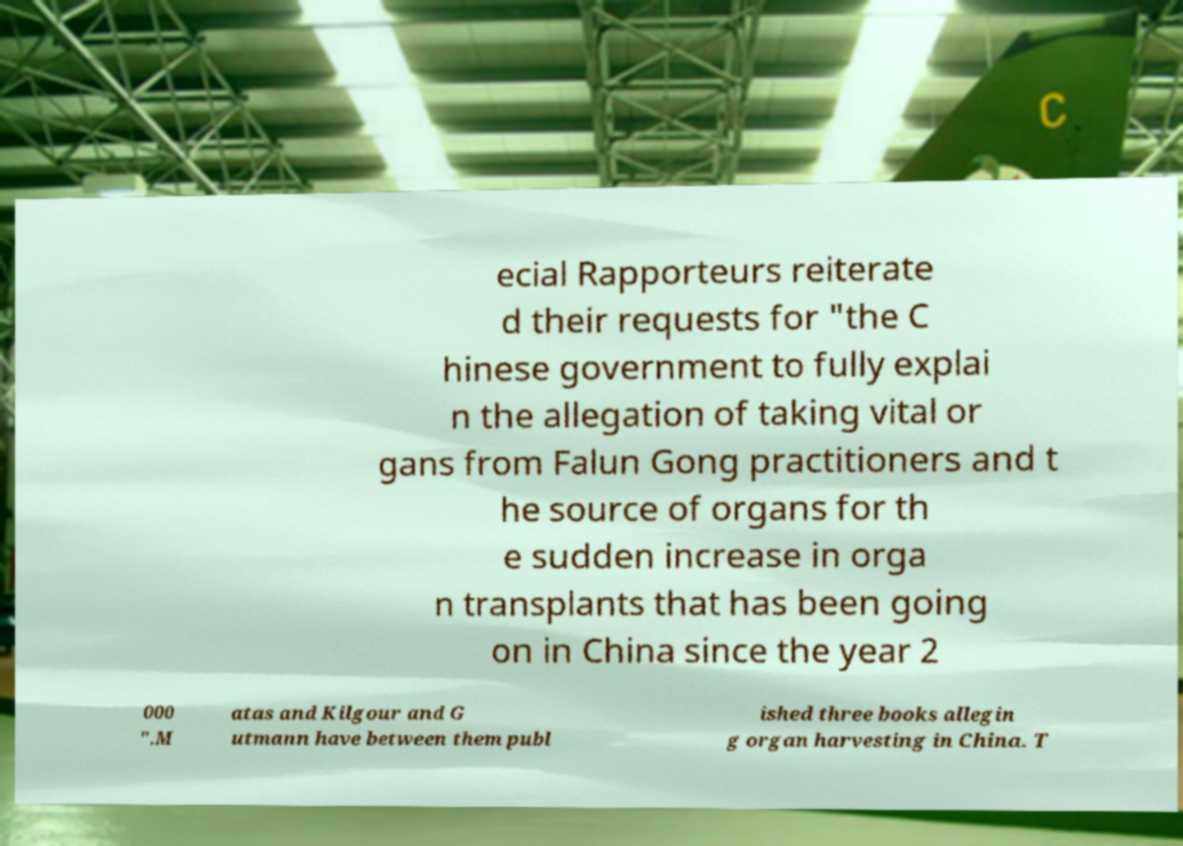Could you assist in decoding the text presented in this image and type it out clearly? ecial Rapporteurs reiterate d their requests for "the C hinese government to fully explai n the allegation of taking vital or gans from Falun Gong practitioners and t he source of organs for th e sudden increase in orga n transplants that has been going on in China since the year 2 000 ".M atas and Kilgour and G utmann have between them publ ished three books allegin g organ harvesting in China. T 